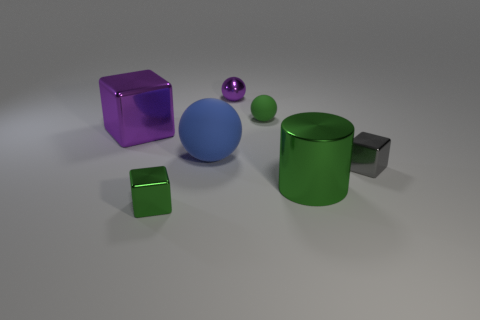Add 3 tiny cubes. How many objects exist? 10 Subtract all cylinders. How many objects are left? 6 Add 3 big matte things. How many big matte things are left? 4 Add 4 matte cylinders. How many matte cylinders exist? 4 Subtract 0 blue blocks. How many objects are left? 7 Subtract all green objects. Subtract all large brown balls. How many objects are left? 4 